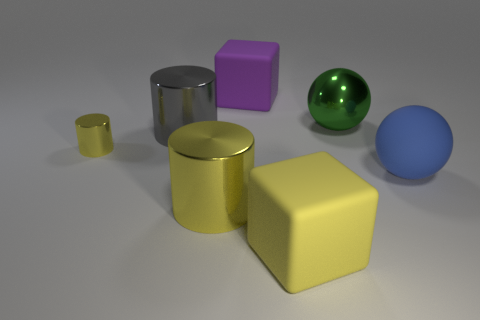There is a block that is the same color as the tiny metallic cylinder; what size is it?
Give a very brief answer. Large. What is the size of the yellow shiny thing behind the big blue thing?
Offer a very short reply. Small. There is a large object that is behind the large gray shiny thing and left of the big yellow cube; what is its shape?
Your answer should be very brief. Cube. Is there a metal cylinder of the same size as the gray shiny thing?
Your response must be concise. Yes. What number of things are either big matte cubes behind the green sphere or large red objects?
Your answer should be compact. 1. Is the big purple cube made of the same material as the sphere that is in front of the tiny thing?
Offer a very short reply. Yes. What number of other objects are the same shape as the blue object?
Give a very brief answer. 1. What number of things are metallic things left of the big purple thing or large matte blocks behind the yellow matte cube?
Your answer should be compact. 4. How many other objects are there of the same color as the small object?
Your answer should be compact. 2. Are there fewer yellow things on the right side of the gray thing than things right of the tiny object?
Your response must be concise. Yes. 